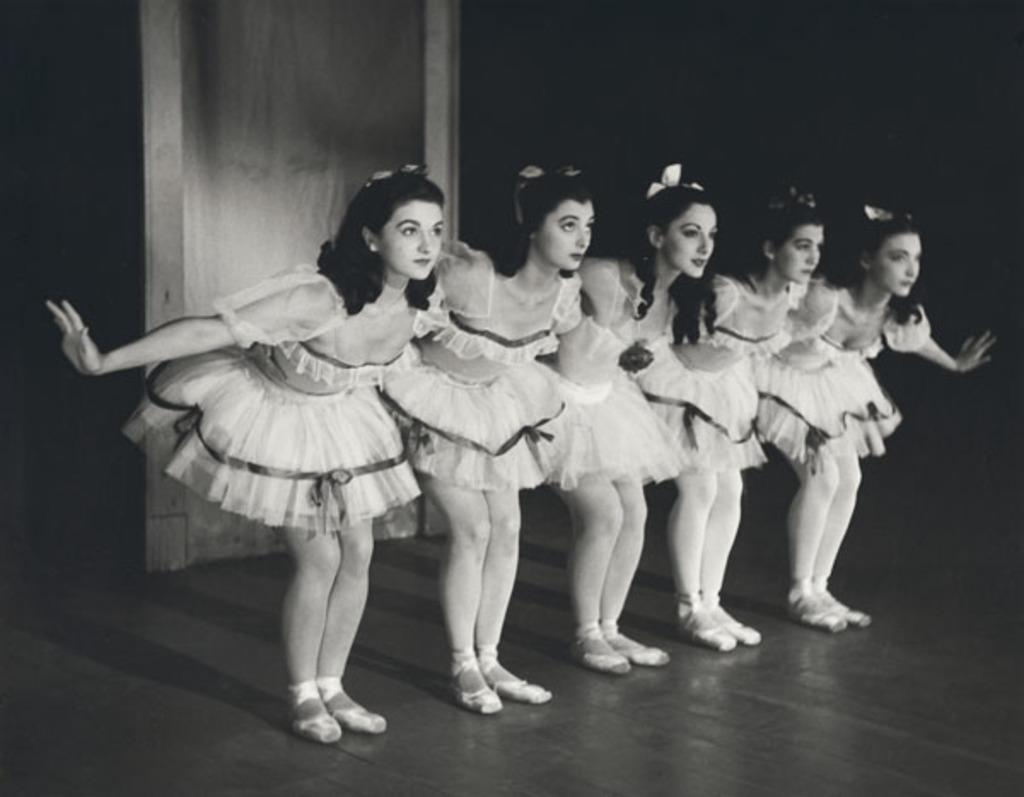What is happening in the image involving a group of people? The people in the image are dancing on a stage. What can be inferred about the setting of the image? The presence of a stage suggests that the image might be from a performance or event. Can you describe any specific objects in the image? Yes, there is a wooden object in the image. What type of war is being depicted in the image? There is no war depicted in the image; it features a group of people dancing on a stage. Can you describe the kitty playing with the wooden object in the image? There is no kitty present in the image; it only features a group of people dancing and a wooden object. 